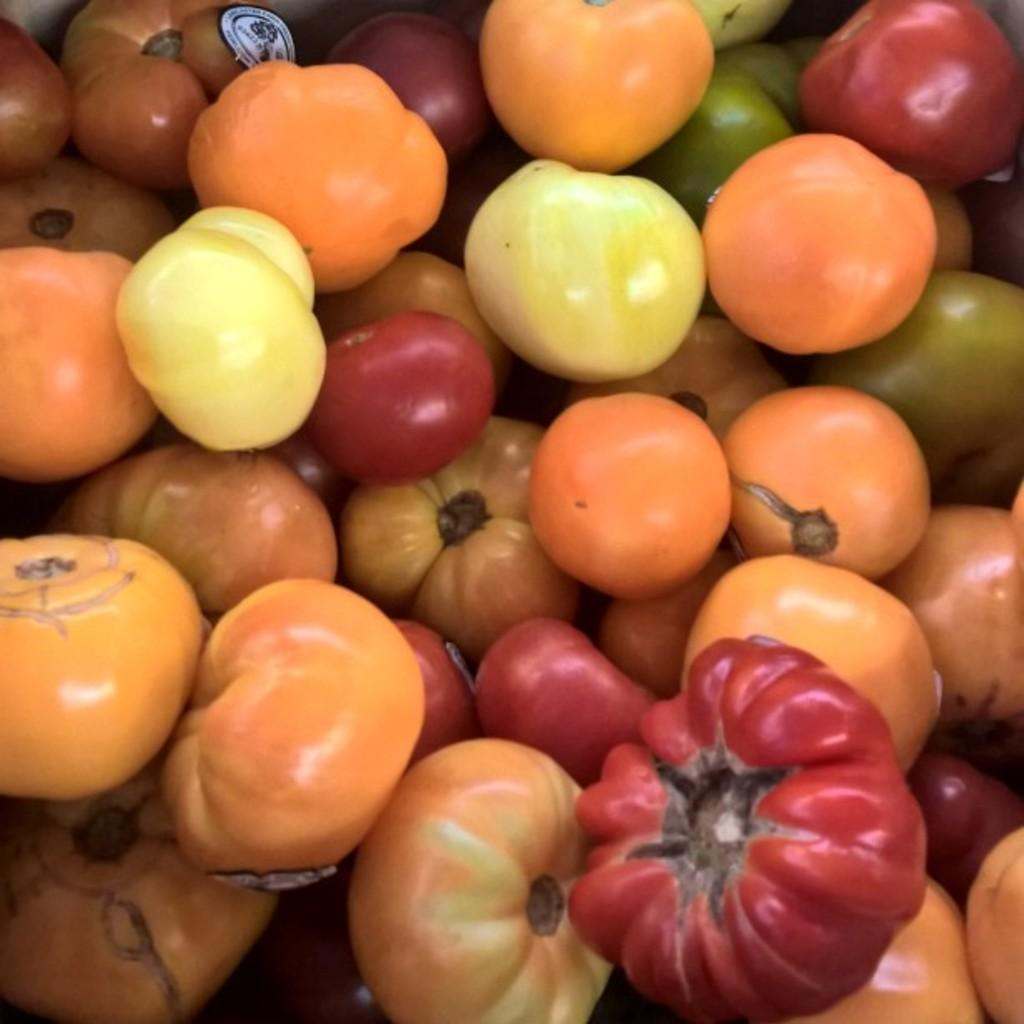What type of fruits are present in the image? There is a group of tomatoes in the image. Can you describe the tomatoes in the image? The tomatoes are in different colors. What type of decision is being made in the hospital regarding the tomatoes in the image? There is no hospital or decision-making process involving the tomatoes in the image. The image simply shows a group of tomatoes in different colors. 